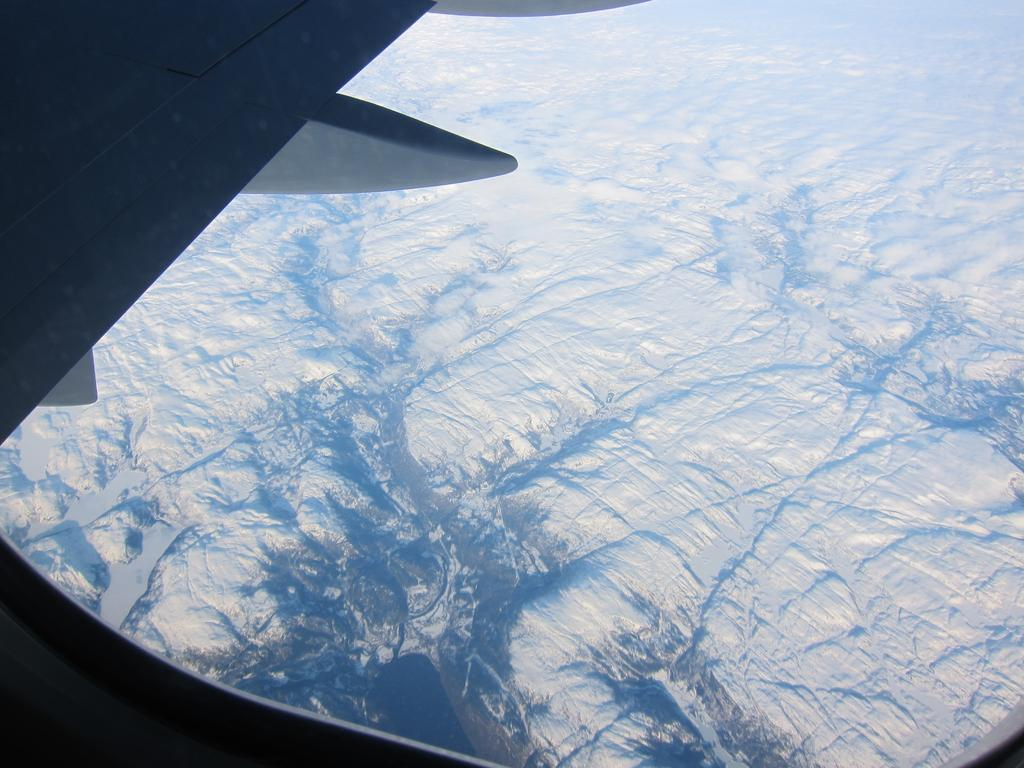What type of location is depicted in the image? The image shows the inside of an aircraft. What part of the aircraft can be seen in the image? A part of the aircraft is visible in the image. What natural feature can be seen outside the aircraft? There are mountains in the image. What type of dress is the doctor wearing while washing their hands in the image? There is no doctor, dress, or hand-washing activity present in the image. 